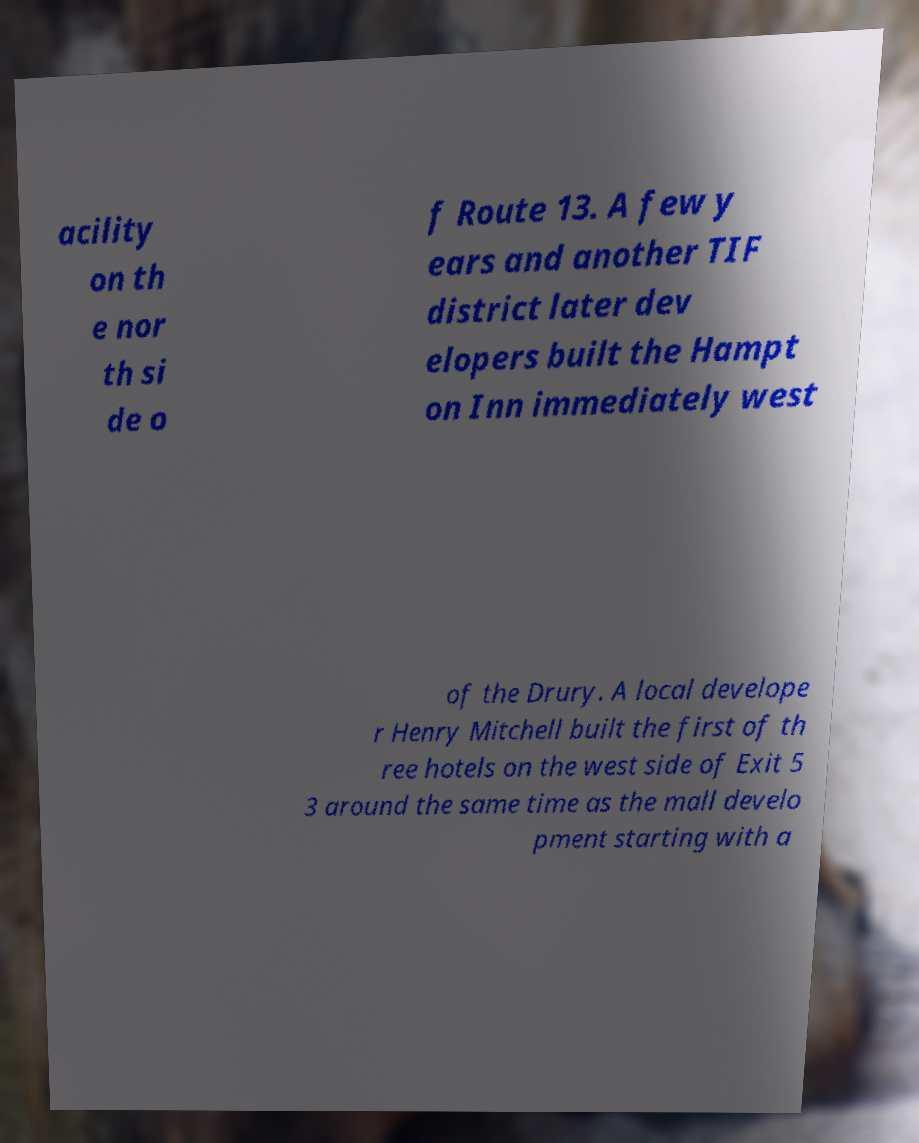Could you assist in decoding the text presented in this image and type it out clearly? acility on th e nor th si de o f Route 13. A few y ears and another TIF district later dev elopers built the Hampt on Inn immediately west of the Drury. A local develope r Henry Mitchell built the first of th ree hotels on the west side of Exit 5 3 around the same time as the mall develo pment starting with a 